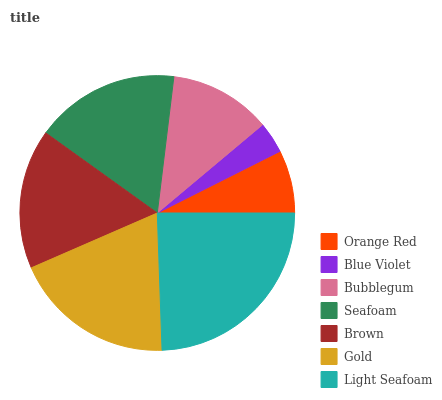Is Blue Violet the minimum?
Answer yes or no. Yes. Is Light Seafoam the maximum?
Answer yes or no. Yes. Is Bubblegum the minimum?
Answer yes or no. No. Is Bubblegum the maximum?
Answer yes or no. No. Is Bubblegum greater than Blue Violet?
Answer yes or no. Yes. Is Blue Violet less than Bubblegum?
Answer yes or no. Yes. Is Blue Violet greater than Bubblegum?
Answer yes or no. No. Is Bubblegum less than Blue Violet?
Answer yes or no. No. Is Brown the high median?
Answer yes or no. Yes. Is Brown the low median?
Answer yes or no. Yes. Is Bubblegum the high median?
Answer yes or no. No. Is Orange Red the low median?
Answer yes or no. No. 